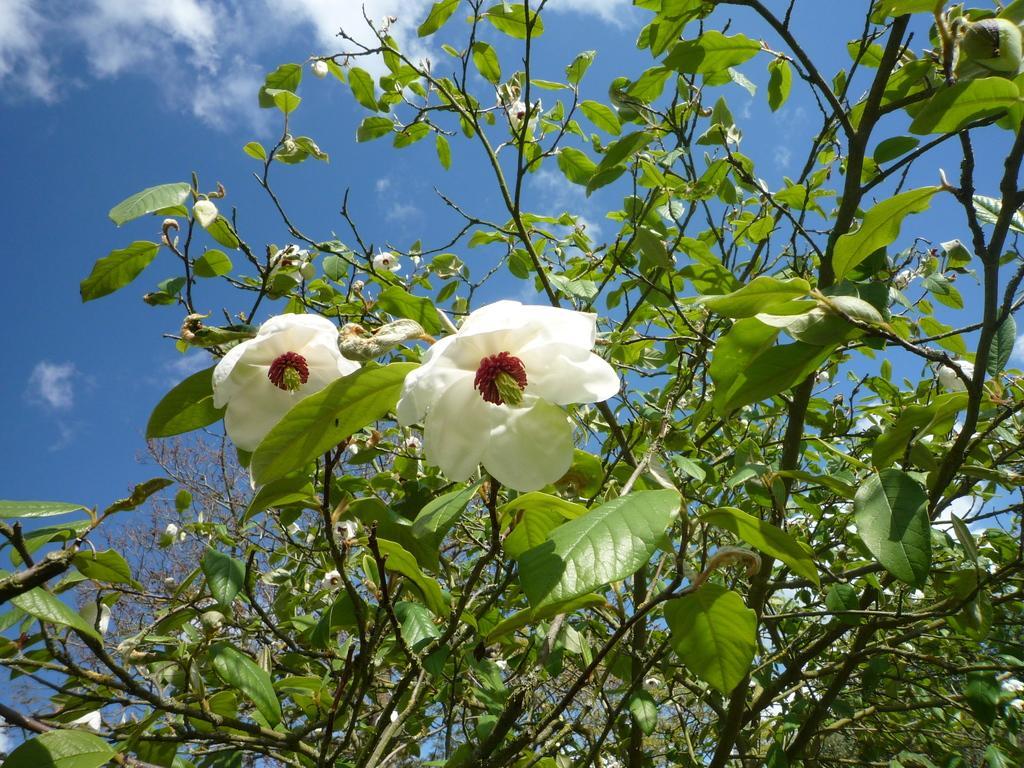In one or two sentences, can you explain what this image depicts? In this image I can see few trees which are green in color and few flowers to it which are white, red and green in color. In the background I can see the sky. 